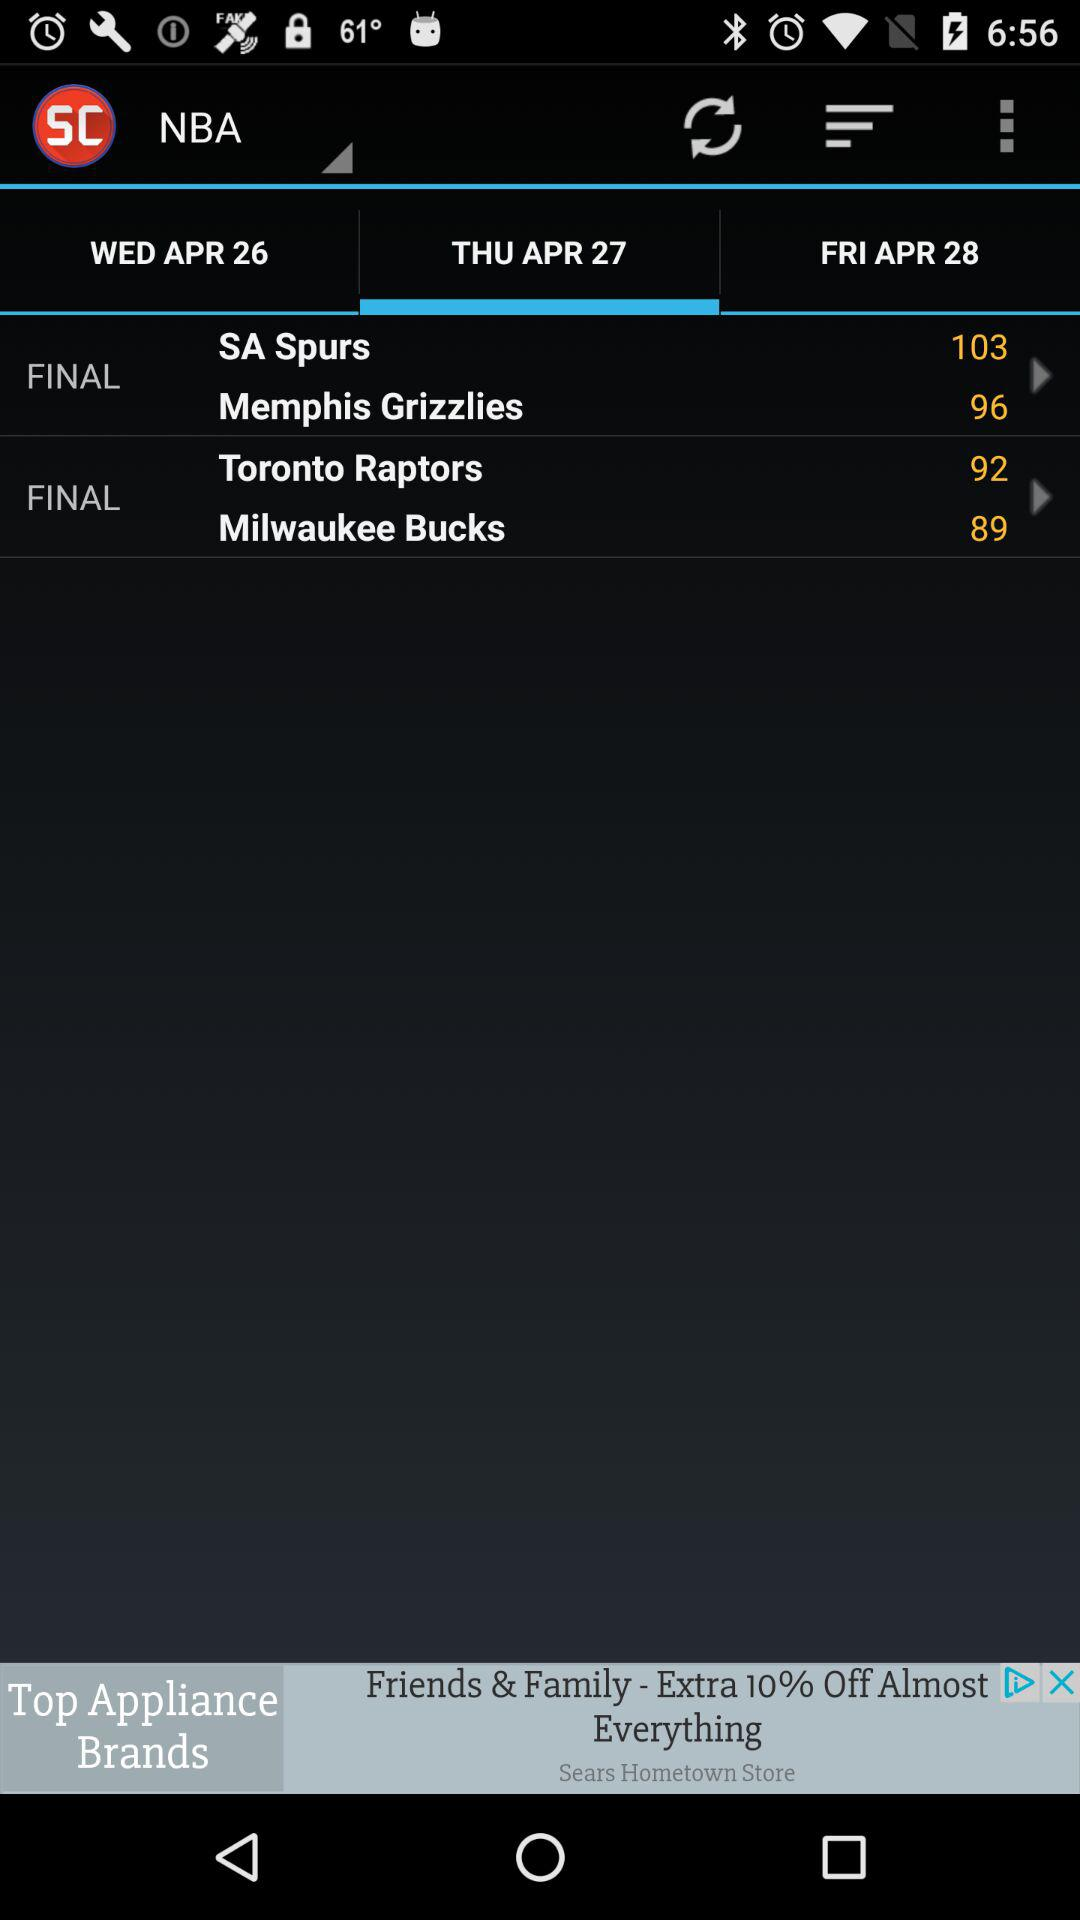What is the day of the selected date? The day is Thursday. 